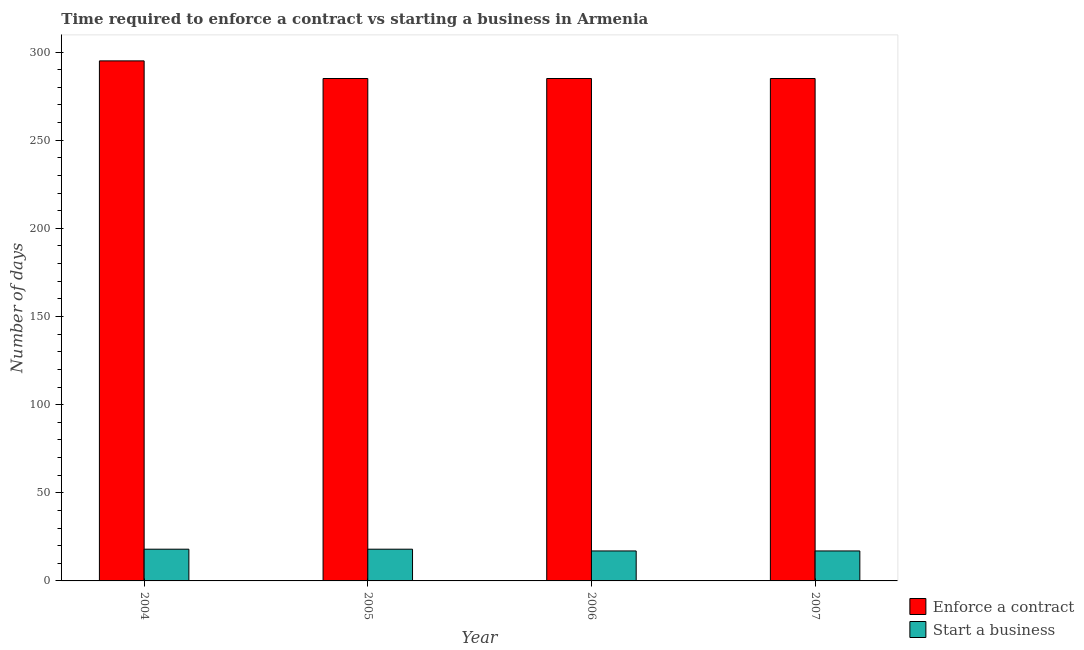How many different coloured bars are there?
Your response must be concise. 2. How many groups of bars are there?
Ensure brevity in your answer.  4. Are the number of bars on each tick of the X-axis equal?
Offer a very short reply. Yes. What is the number of days to enforece a contract in 2006?
Your response must be concise. 285. Across all years, what is the maximum number of days to enforece a contract?
Ensure brevity in your answer.  295. Across all years, what is the minimum number of days to start a business?
Offer a very short reply. 17. In which year was the number of days to enforece a contract maximum?
Make the answer very short. 2004. What is the total number of days to start a business in the graph?
Your answer should be compact. 70. What is the difference between the number of days to start a business in 2006 and the number of days to enforece a contract in 2004?
Provide a succinct answer. -1. What is the average number of days to enforece a contract per year?
Your answer should be very brief. 287.5. What is the ratio of the number of days to start a business in 2004 to that in 2006?
Offer a terse response. 1.06. What is the difference between the highest and the lowest number of days to start a business?
Offer a very short reply. 1. What does the 1st bar from the left in 2007 represents?
Provide a short and direct response. Enforce a contract. What does the 2nd bar from the right in 2004 represents?
Your answer should be compact. Enforce a contract. Are all the bars in the graph horizontal?
Your response must be concise. No. How many years are there in the graph?
Provide a short and direct response. 4. Are the values on the major ticks of Y-axis written in scientific E-notation?
Your answer should be very brief. No. Does the graph contain any zero values?
Your answer should be compact. No. Does the graph contain grids?
Give a very brief answer. No. Where does the legend appear in the graph?
Your answer should be very brief. Bottom right. How many legend labels are there?
Keep it short and to the point. 2. What is the title of the graph?
Provide a short and direct response. Time required to enforce a contract vs starting a business in Armenia. What is the label or title of the X-axis?
Offer a very short reply. Year. What is the label or title of the Y-axis?
Your answer should be very brief. Number of days. What is the Number of days of Enforce a contract in 2004?
Keep it short and to the point. 295. What is the Number of days in Enforce a contract in 2005?
Give a very brief answer. 285. What is the Number of days in Enforce a contract in 2006?
Give a very brief answer. 285. What is the Number of days in Start a business in 2006?
Your response must be concise. 17. What is the Number of days in Enforce a contract in 2007?
Provide a succinct answer. 285. Across all years, what is the maximum Number of days in Enforce a contract?
Provide a succinct answer. 295. Across all years, what is the minimum Number of days of Enforce a contract?
Provide a short and direct response. 285. Across all years, what is the minimum Number of days of Start a business?
Provide a succinct answer. 17. What is the total Number of days in Enforce a contract in the graph?
Offer a very short reply. 1150. What is the difference between the Number of days of Enforce a contract in 2004 and that in 2005?
Keep it short and to the point. 10. What is the difference between the Number of days in Start a business in 2004 and that in 2006?
Your response must be concise. 1. What is the difference between the Number of days of Enforce a contract in 2004 and that in 2007?
Ensure brevity in your answer.  10. What is the difference between the Number of days in Enforce a contract in 2005 and that in 2006?
Provide a succinct answer. 0. What is the difference between the Number of days in Start a business in 2005 and that in 2006?
Give a very brief answer. 1. What is the difference between the Number of days of Enforce a contract in 2006 and that in 2007?
Keep it short and to the point. 0. What is the difference between the Number of days of Enforce a contract in 2004 and the Number of days of Start a business in 2005?
Make the answer very short. 277. What is the difference between the Number of days of Enforce a contract in 2004 and the Number of days of Start a business in 2006?
Offer a terse response. 278. What is the difference between the Number of days of Enforce a contract in 2004 and the Number of days of Start a business in 2007?
Provide a short and direct response. 278. What is the difference between the Number of days in Enforce a contract in 2005 and the Number of days in Start a business in 2006?
Offer a very short reply. 268. What is the difference between the Number of days in Enforce a contract in 2005 and the Number of days in Start a business in 2007?
Your answer should be compact. 268. What is the difference between the Number of days of Enforce a contract in 2006 and the Number of days of Start a business in 2007?
Provide a short and direct response. 268. What is the average Number of days in Enforce a contract per year?
Your answer should be very brief. 287.5. What is the average Number of days in Start a business per year?
Provide a succinct answer. 17.5. In the year 2004, what is the difference between the Number of days of Enforce a contract and Number of days of Start a business?
Make the answer very short. 277. In the year 2005, what is the difference between the Number of days of Enforce a contract and Number of days of Start a business?
Make the answer very short. 267. In the year 2006, what is the difference between the Number of days of Enforce a contract and Number of days of Start a business?
Your response must be concise. 268. In the year 2007, what is the difference between the Number of days in Enforce a contract and Number of days in Start a business?
Give a very brief answer. 268. What is the ratio of the Number of days in Enforce a contract in 2004 to that in 2005?
Offer a terse response. 1.04. What is the ratio of the Number of days in Start a business in 2004 to that in 2005?
Ensure brevity in your answer.  1. What is the ratio of the Number of days of Enforce a contract in 2004 to that in 2006?
Provide a succinct answer. 1.04. What is the ratio of the Number of days in Start a business in 2004 to that in 2006?
Your response must be concise. 1.06. What is the ratio of the Number of days in Enforce a contract in 2004 to that in 2007?
Provide a succinct answer. 1.04. What is the ratio of the Number of days in Start a business in 2004 to that in 2007?
Your answer should be very brief. 1.06. What is the ratio of the Number of days in Enforce a contract in 2005 to that in 2006?
Provide a short and direct response. 1. What is the ratio of the Number of days in Start a business in 2005 to that in 2006?
Keep it short and to the point. 1.06. What is the ratio of the Number of days in Start a business in 2005 to that in 2007?
Offer a very short reply. 1.06. What is the difference between the highest and the second highest Number of days in Enforce a contract?
Your answer should be very brief. 10. What is the difference between the highest and the second highest Number of days of Start a business?
Provide a succinct answer. 0. What is the difference between the highest and the lowest Number of days in Enforce a contract?
Your answer should be compact. 10. 